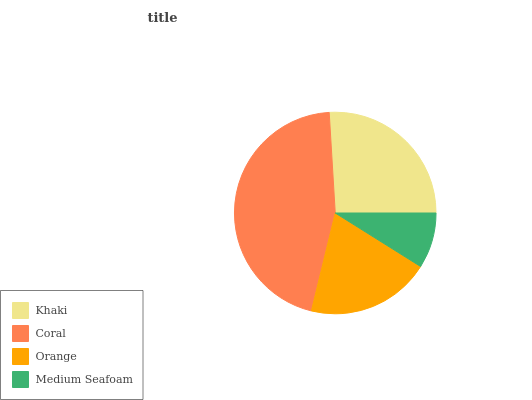Is Medium Seafoam the minimum?
Answer yes or no. Yes. Is Coral the maximum?
Answer yes or no. Yes. Is Orange the minimum?
Answer yes or no. No. Is Orange the maximum?
Answer yes or no. No. Is Coral greater than Orange?
Answer yes or no. Yes. Is Orange less than Coral?
Answer yes or no. Yes. Is Orange greater than Coral?
Answer yes or no. No. Is Coral less than Orange?
Answer yes or no. No. Is Khaki the high median?
Answer yes or no. Yes. Is Orange the low median?
Answer yes or no. Yes. Is Coral the high median?
Answer yes or no. No. Is Coral the low median?
Answer yes or no. No. 